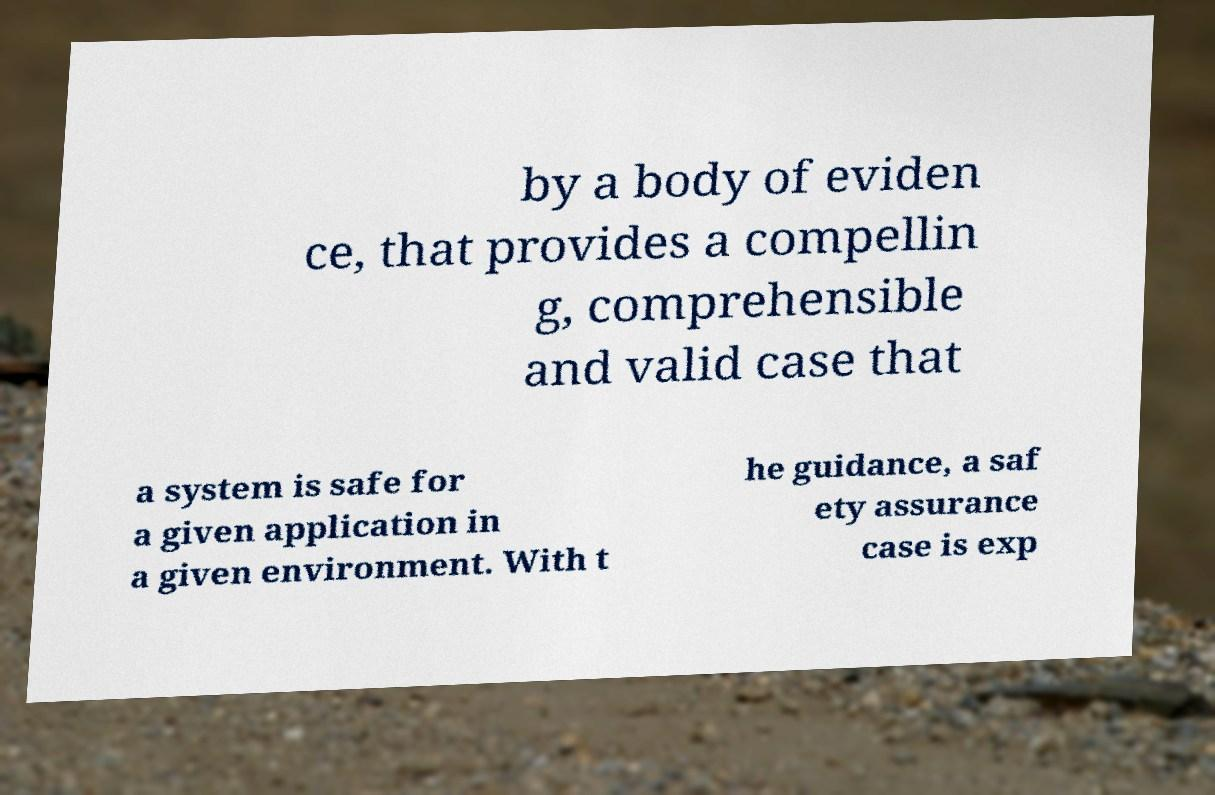What messages or text are displayed in this image? I need them in a readable, typed format. by a body of eviden ce, that provides a compellin g, comprehensible and valid case that a system is safe for a given application in a given environment. With t he guidance, a saf ety assurance case is exp 